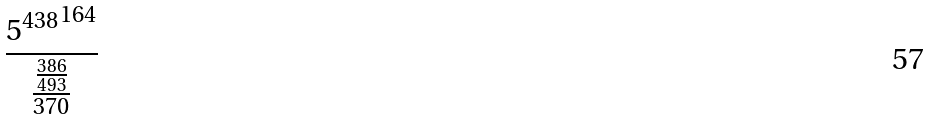Convert formula to latex. <formula><loc_0><loc_0><loc_500><loc_500>\frac { { 5 ^ { 4 3 8 } } ^ { 1 6 4 } } { \frac { \frac { 3 8 6 } { 4 9 3 } } { 3 7 0 } }</formula> 